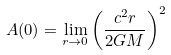Convert formula to latex. <formula><loc_0><loc_0><loc_500><loc_500>A ( 0 ) = \lim _ { r \rightarrow 0 } \left ( \frac { c ^ { 2 } r } { 2 G M } \right ) ^ { 2 }</formula> 